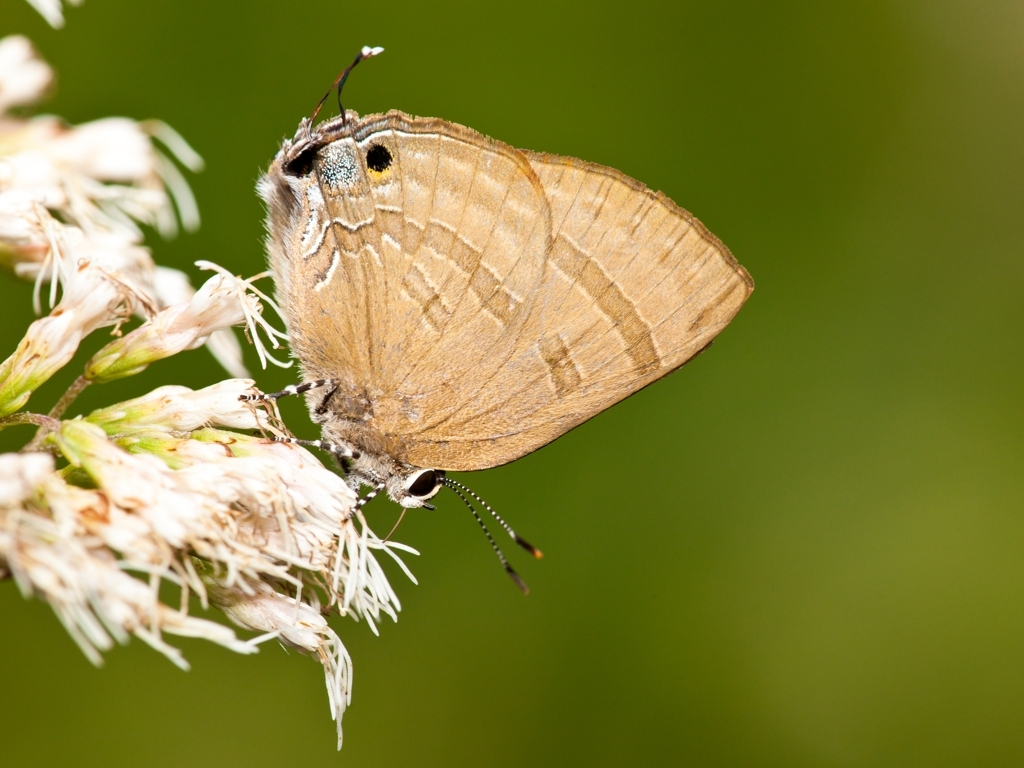Are there any quality issues with this image? The image is of high quality, with the subject, a butterfly, in sharp focus against a blurred green background which provides a pleasing bokeh effect. The lighting is even, the colors are vibrant, and there's no noticeable noise, suggesting good exposure and a high-resolution capture. There are no apparent quality issues with this image. 